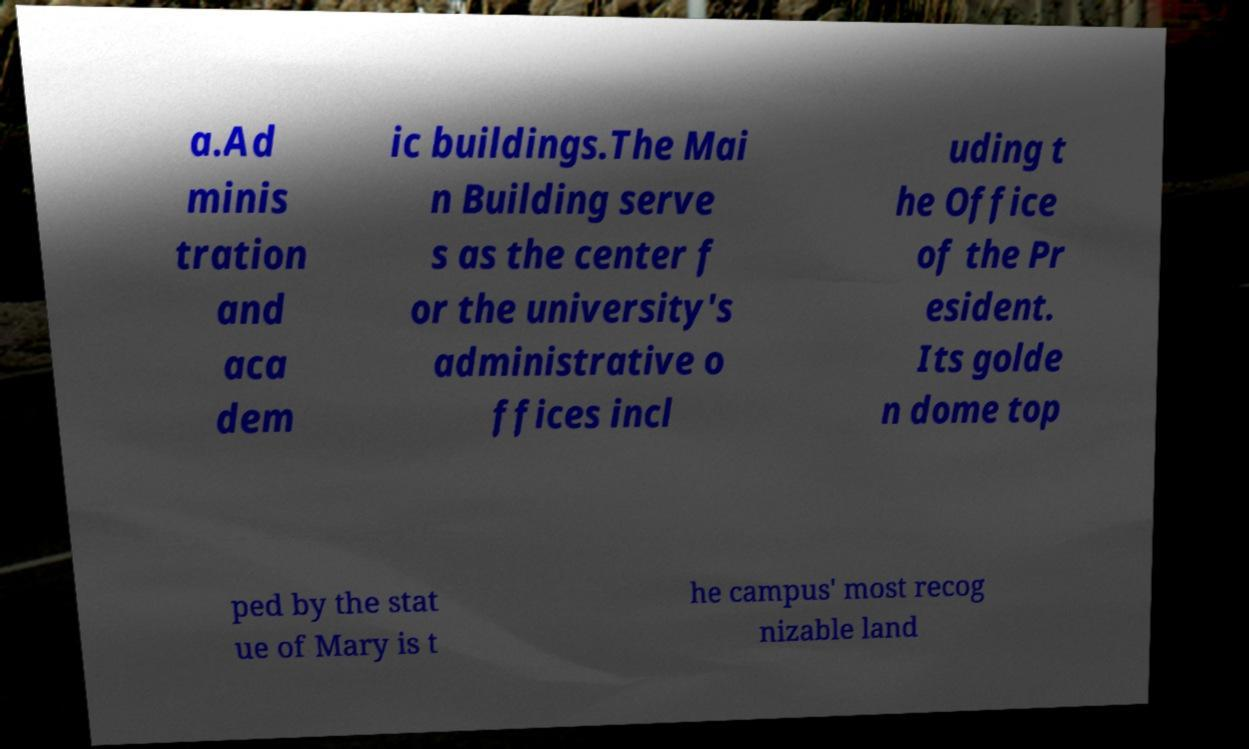Can you accurately transcribe the text from the provided image for me? a.Ad minis tration and aca dem ic buildings.The Mai n Building serve s as the center f or the university's administrative o ffices incl uding t he Office of the Pr esident. Its golde n dome top ped by the stat ue of Mary is t he campus' most recog nizable land 